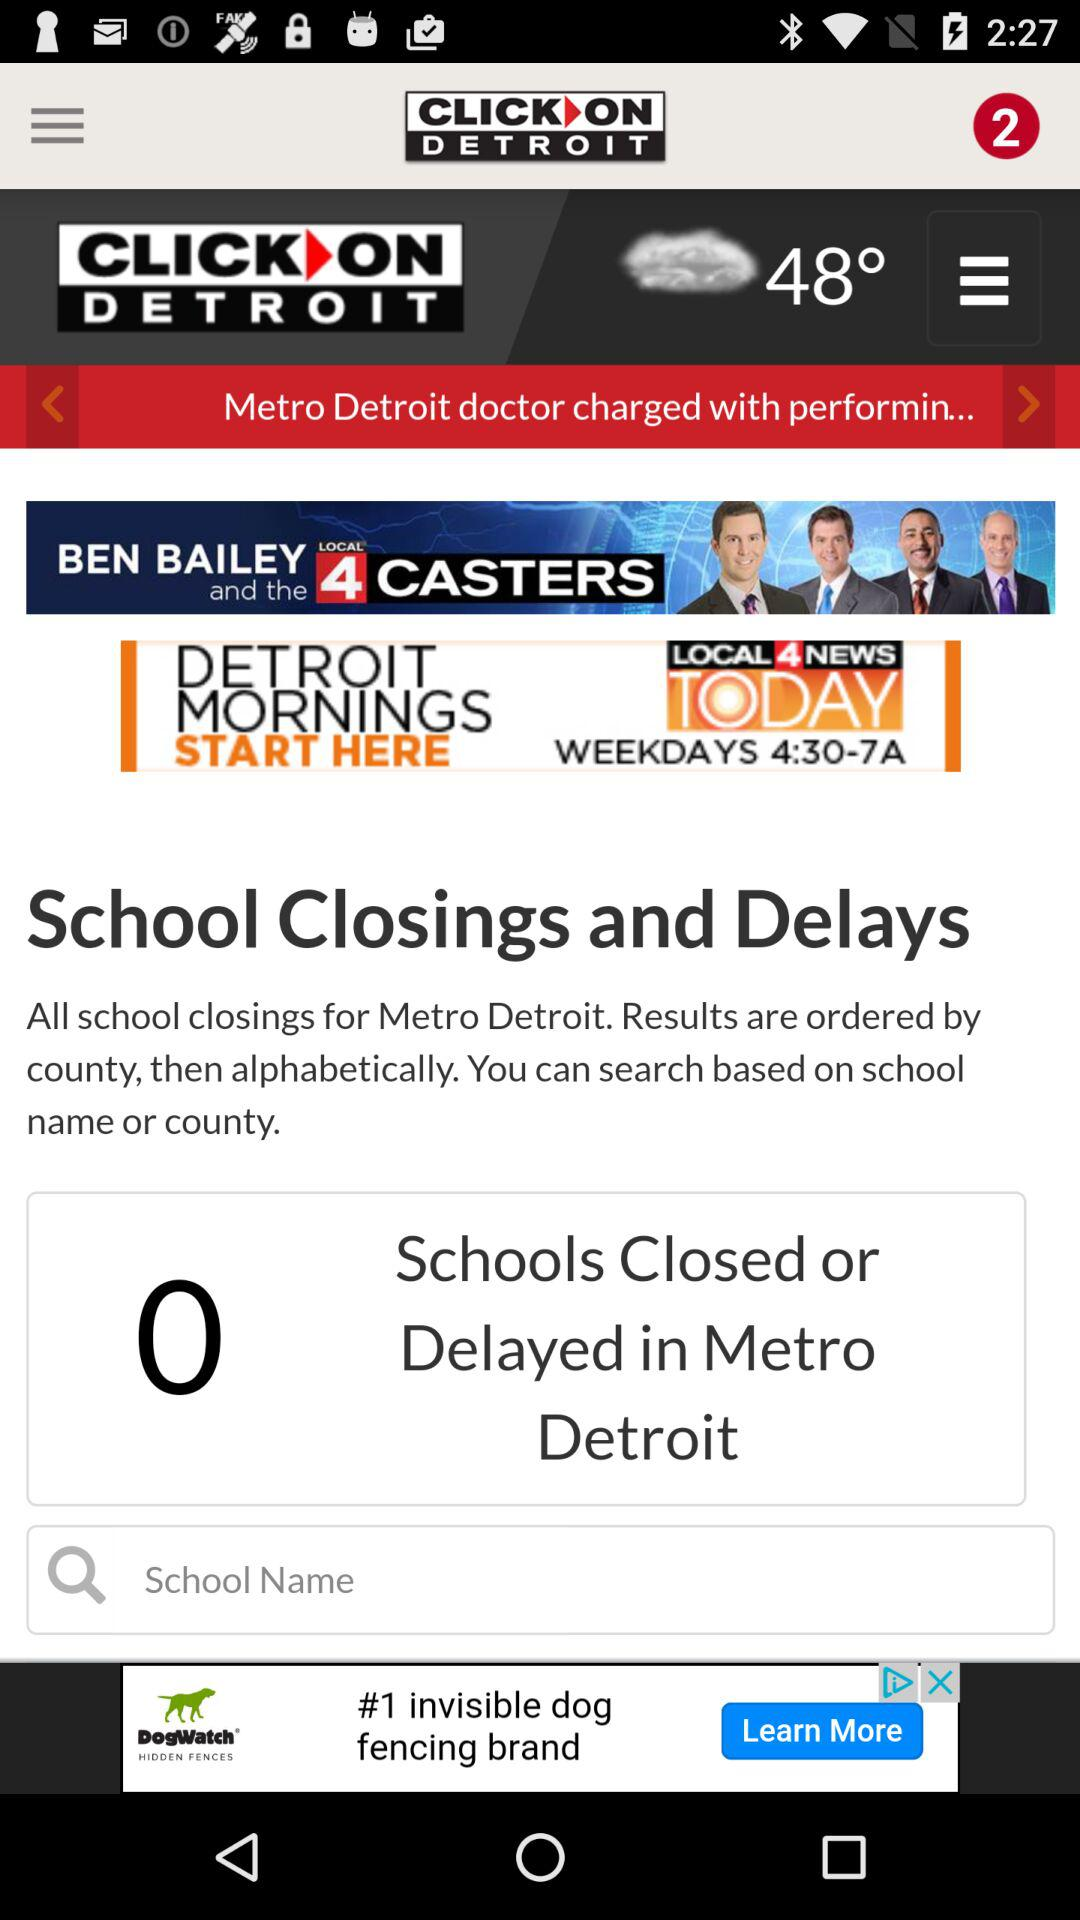What is the temperature? The temperature is 48°. 